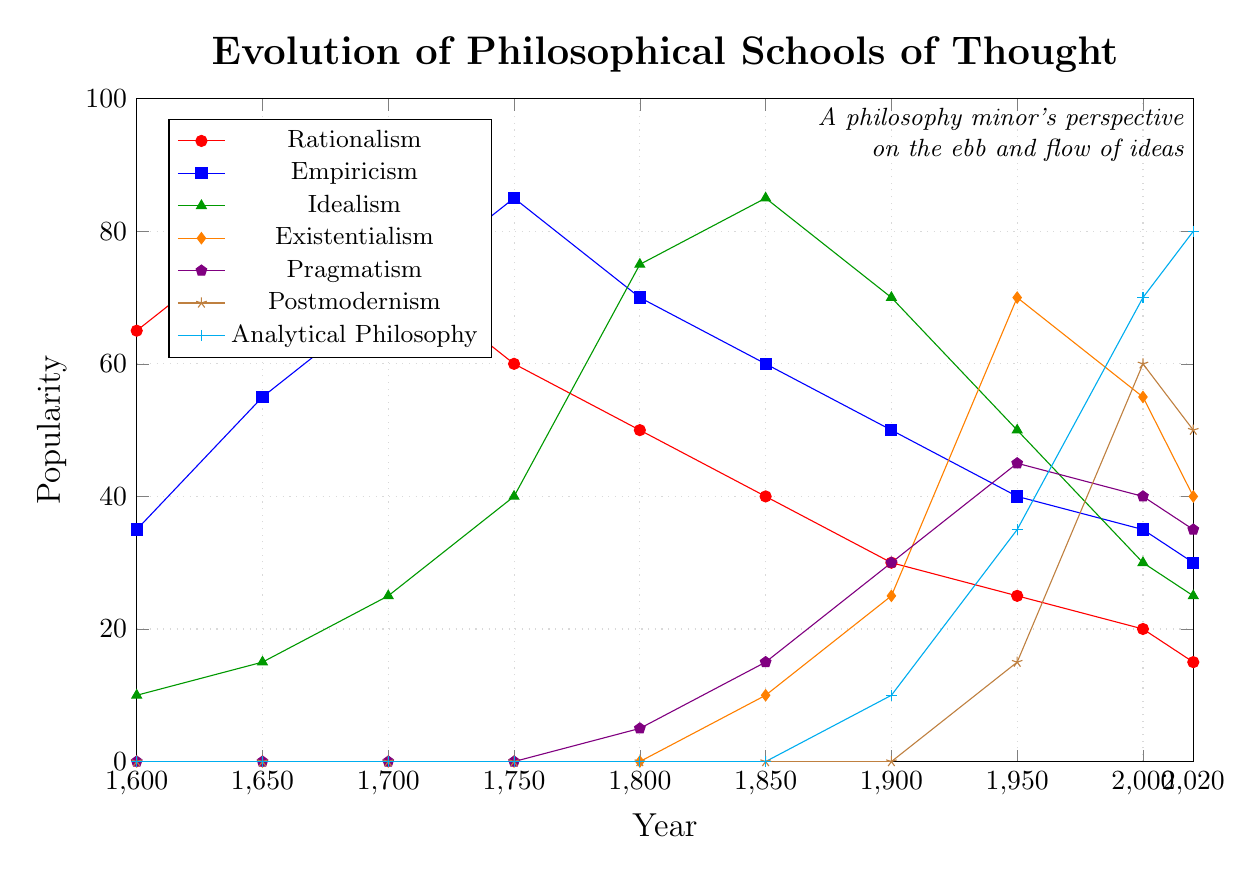What is the trend in popularity of Rationalism from 1600 to 2020? To analyze the trend, observe the change in Rationalism's popularity over each time interval. The values decrease progressively from 65 in 1600 to 15 in 2020. Thus, the trend is a consistent decline.
Answer: Decline Between which periods did Empiricism see the greatest increase in popularity? To determine this, examine the differences in Empiricism's popularity over each time period. The largest increase occurs between 1650 and 1750, rising from 55 to 85.
Answer: 1650-1750 How does the popularity of Existentialism in 1950 compare to that of Idealism in 1850? Check the exact values for both points: Existentialism in 1950 is 70, and Idealism in 1850 is 85. Therefore, Idealism in 1850 is more popular.
Answer: Idealism in 1850 is more popular Which philosophical school had the highest popularity in 2020? Look at the data for all schools in 2020 and identify the highest value. Analytical Philosophy is at 80, which is the highest among all.
Answer: Analytical Philosophy In what year did Pragmatism first appear on the chart? The first non-zero value for Pragmatism is in 1800, where its value is 5. This indicates its first appearance.
Answer: 1800 Which philosophical school had the most significant drop in popularity between 2000 and 2020? Calculate the drop for each school between 2000 and 2020. Rationalism dropped from 20 to 15, Empiricism from 35 to 30, Idealism from 30 to 25, Existentialism from 55 to 40, Pragmatism from 40 to 35, Postmodernism from 60 to 50, and Analytical Philosophy increased. Existentialism’s drop of 15 is the most significant among the declines.
Answer: Existentialism Compare the average popularity of Empiricism over the entire period with that of Postmodernism. First, find the sum of Empiricism's values (35, 55, 70, 85, 70, 60, 50, 40, 35, 30) and divide by 10: (530/10 = 53). For Postmodernism, sum values (0, 0, 0, 0, 0, 0, 0, 15, 60, 50) and divide by 10: (125/10 = 12.5). Empiricism's average (53) is higher.
Answer: Empiricism Which school experienced the most significant rise in popularity during the 20th century (1900-2000)? Calculate the difference for each school from 1900 to 2000 and compare: Rationalism (30 to 20, -10), Empiricism (50 to 35, -15), Idealism (70 to 30, -40), Existentialism (25 to 55, +30), Pragmatism (30 to 40, +10), Postmodernism (0 to 60, +60), Analytical Philosophy (10 to 70, +60). Analytical Philosophy and Postmodernism both rose by 60, the most significant change.
Answer: Analytical Philosophy and Postmodernism What is the total increase in popularity for Analytical Philosophy from 1900 to 2020? Calculate the difference between the 2020 and 1900 values for Analytical Philosophy: 80 (2020) - 10 (1900) = 70.
Answer: 70 Which philosophical school was the least popular in 1850? Identify the lowest value among all schools in 1850. Postmodernism and Analytical Philosophy both have a value of 0, being the least popular.
Answer: Postmodernism and Analytical Philosophy 